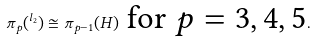Convert formula to latex. <formula><loc_0><loc_0><loc_500><loc_500>\label l { e \colon p i p l 2 - 2 } \pi _ { p } ( ^ { l _ { 2 } } ) \cong \pi _ { p - 1 } ( H ) \text { for $p=3,4,5$} .</formula> 